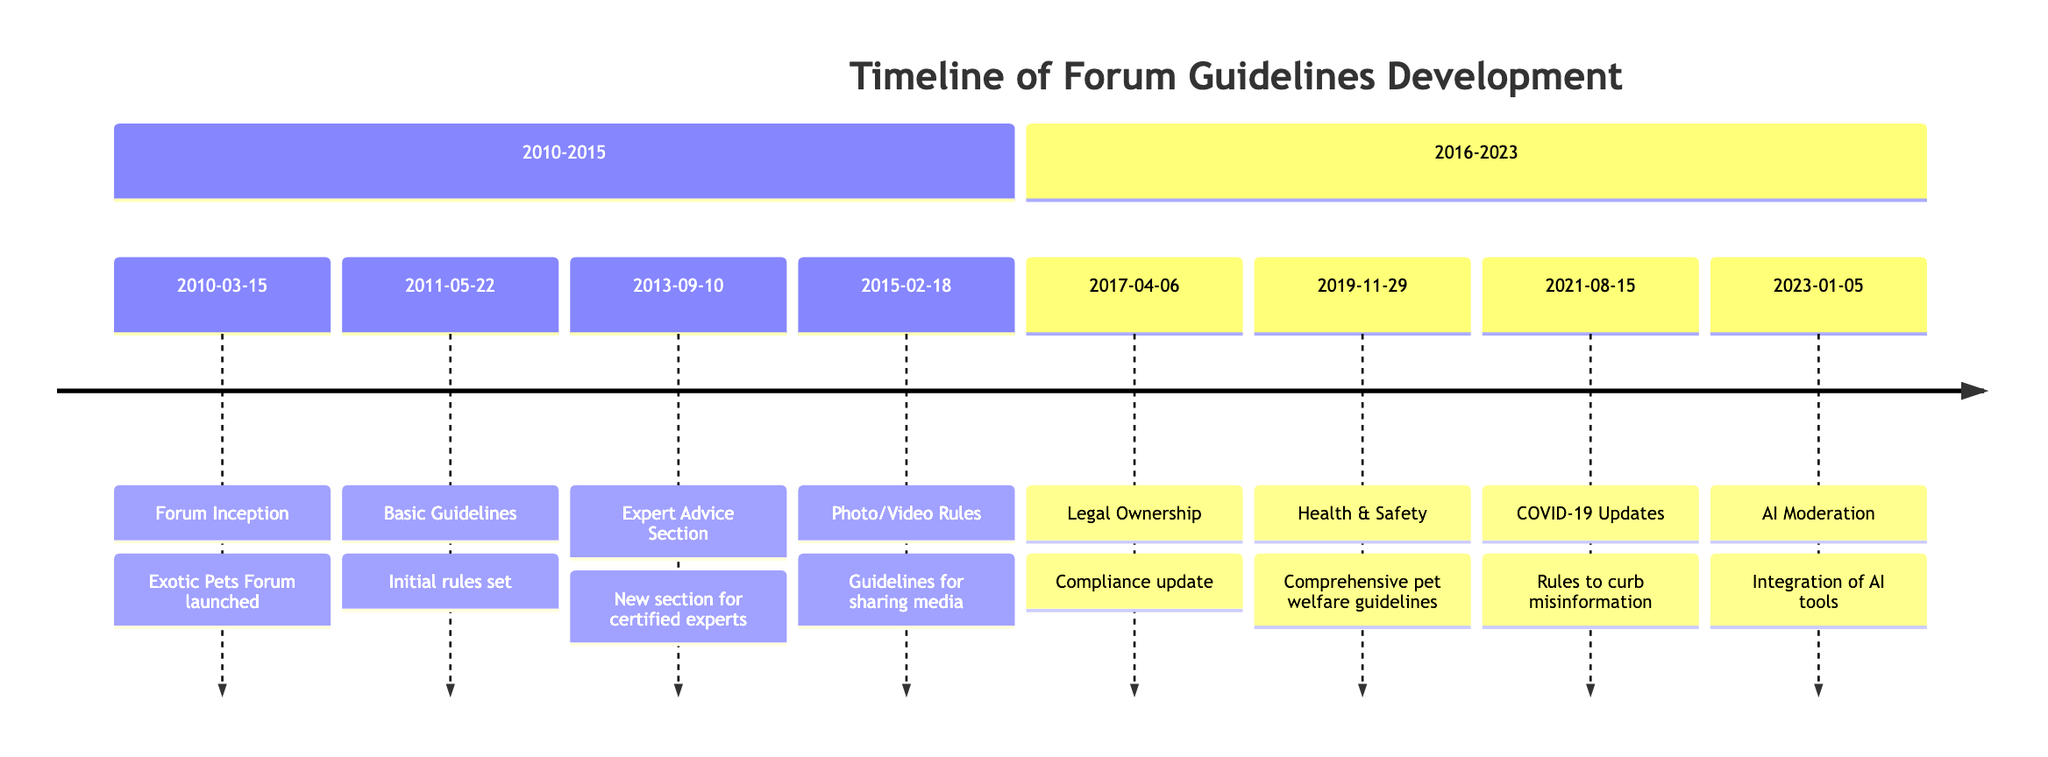What is the date of the forum inception? The first entry in the timeline indicates that the forum was officially launched on March 15, 2010.
Answer: 2010-03-15 How many major updates were introduced between 2016 and 2023? From the timeline, we can see there are four major updates listed in the section spanning 2016 to 2023: Legal Ownership, Health & Safety, COVID-19 Updates, and AI Moderation. This provides a total of four updates.
Answer: 4 What significant section was created in 2013? The timeline states that on September 10, 2013, the "Expert Advice Section" was created for certified exotic pet experts.
Answer: Expert Advice Section What guideline was introduced on February 18, 2015? According to the entry on February 18, 2015, new rules outlining the "Photo and Video Upload Rules" were introduced to ensure pet safety and respect in shared media.
Answer: Photo and Video Upload Rules Which update specifically addresses misinformation about pets and COVID-19? The timeline notes that on August 15, 2021, new rules were added regarding COVID-19, aimed at curbing misinformation relating to pets during the pandemic.
Answer: COVID-19 Related Updates What was the main focus of the guidelines introduced on November 29, 2019? The guidelines implemented on November 29, 2019, focused on "Health and Safety," addressing the welfare of exotic pets within the forum.
Answer: Health and Safety Guidelines List the year when AI moderation tools were integrated. The timeline indicates that AI moderation tools were introduced on January 5, 2023.
Answer: 2023 What type of ownership verification was introduced in 2017? The compliance update introduced on April 6, 2017, required users to verify their "legal ownership" of exotic pets before sharing particular types of content.
Answer: Legal Ownership How many years separate the introduction of the Expert Advice Section and the COVID-19 Related Updates? The Expert Advice Section was established on September 10, 2013, and the COVID-19 Related Updates were introduced on August 15, 2021. Calculating the difference between 2021 and 2013 yields eight years.
Answer: 8 